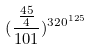<formula> <loc_0><loc_0><loc_500><loc_500>( \frac { \frac { 4 5 } { 4 } } { 1 0 1 } ) ^ { 3 2 0 ^ { 1 2 5 } }</formula> 